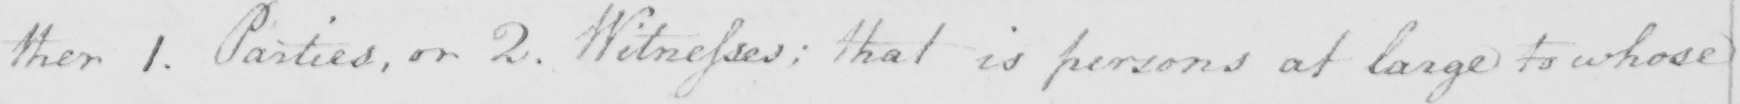Can you read and transcribe this handwriting? : ther 1 . Parties , or 2 . Witnesses :  that is persons at large to whose 